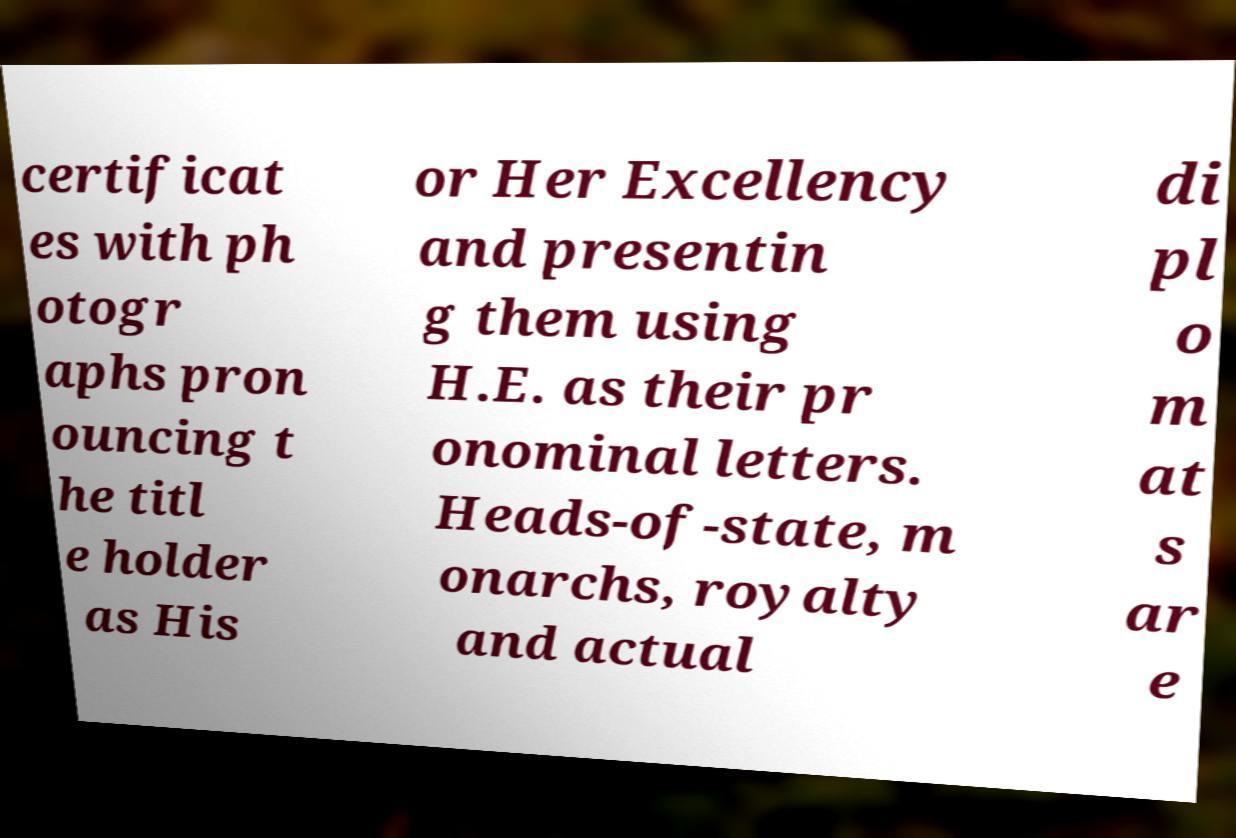Can you read and provide the text displayed in the image?This photo seems to have some interesting text. Can you extract and type it out for me? certificat es with ph otogr aphs pron ouncing t he titl e holder as His or Her Excellency and presentin g them using H.E. as their pr onominal letters. Heads-of-state, m onarchs, royalty and actual di pl o m at s ar e 